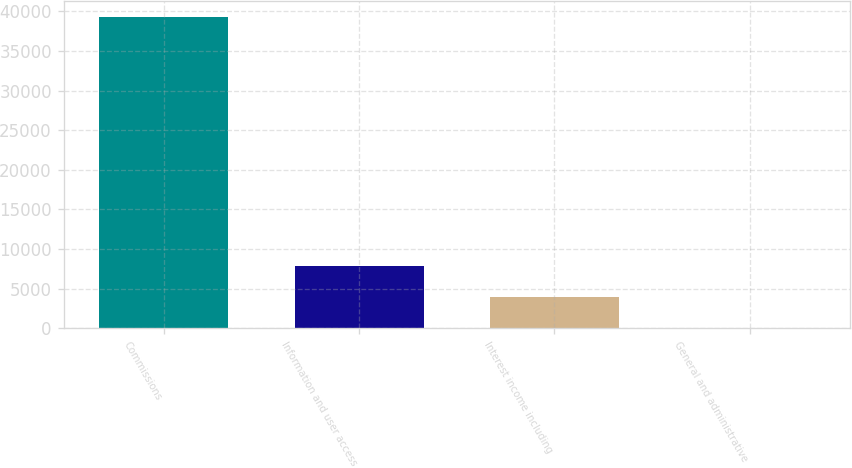Convert chart. <chart><loc_0><loc_0><loc_500><loc_500><bar_chart><fcel>Commissions<fcel>Information and user access<fcel>Interest income including<fcel>General and administrative<nl><fcel>39307<fcel>7881.4<fcel>3953.2<fcel>25<nl></chart> 